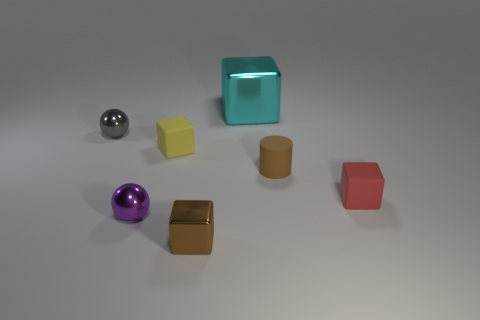What textures are visible on the objects, and what might this imply about their materials? In the image, we can observe objects with different textures: the silver and purple spheres have a smooth, reflective surface, indicating they might be metallic or plastic; the teal cube appears translucent and slightly reflective, hinting at a glass or acrylic make; the yellow cube has a solid, matte surface suggesting a non-reflective plastic or possibly a painted wood; the cylindrical brown object has a duller, perhaps rubbery texture; and the matte red cube suggests a similar material to the yellow cube. These textures give us clues about their materials, ranging from metals and plastics to possibly rubber and wood. 